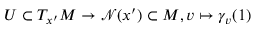<formula> <loc_0><loc_0><loc_500><loc_500>U \subset T _ { x ^ { \prime } } M \rightarrow \mathcal { N } ( x ^ { \prime } ) \subset M , v \mapsto \gamma _ { v } ( 1 )</formula> 